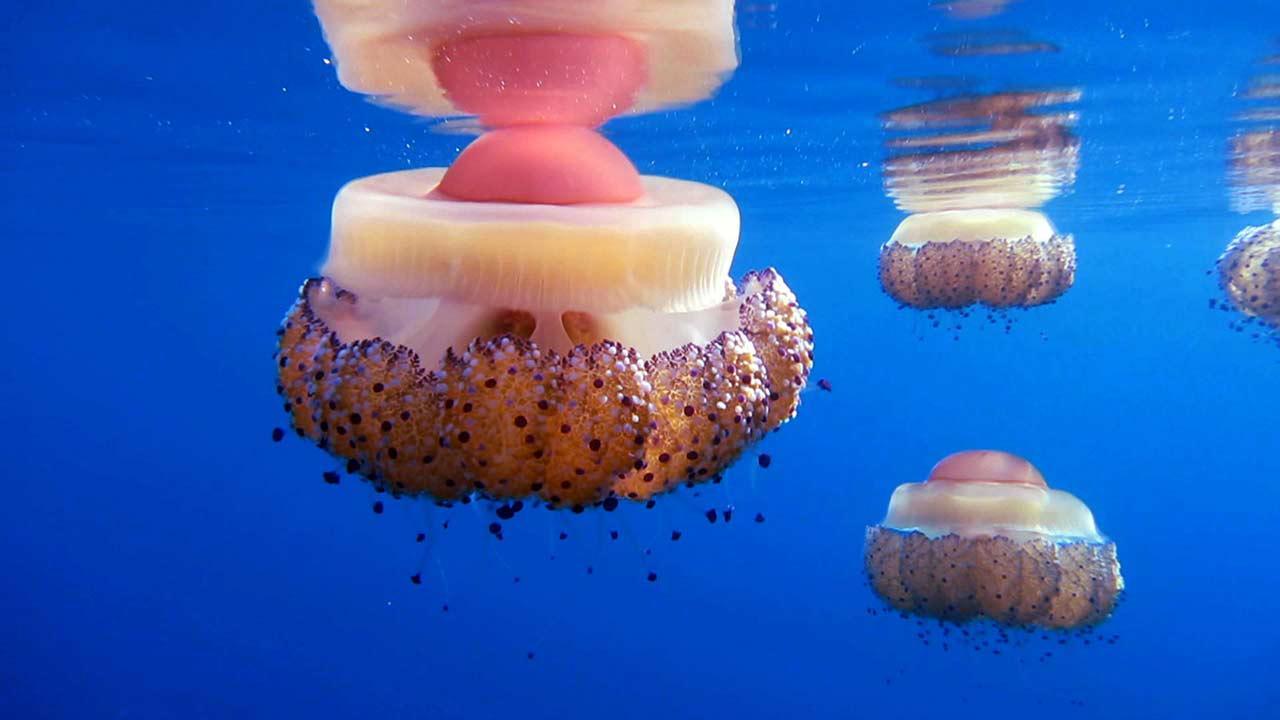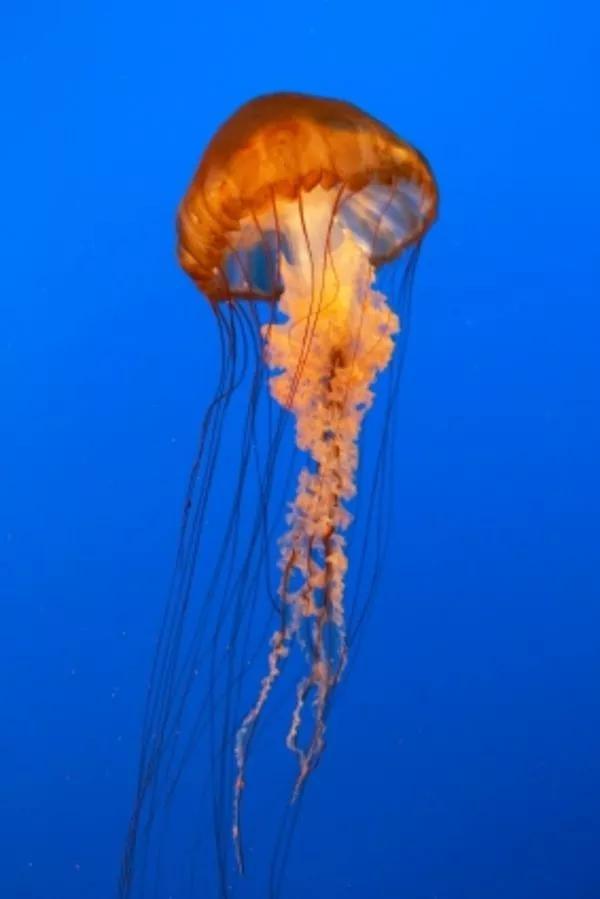The first image is the image on the left, the second image is the image on the right. Examine the images to the left and right. Is the description "the left pic has more then three creatures" accurate? Answer yes or no. Yes. 